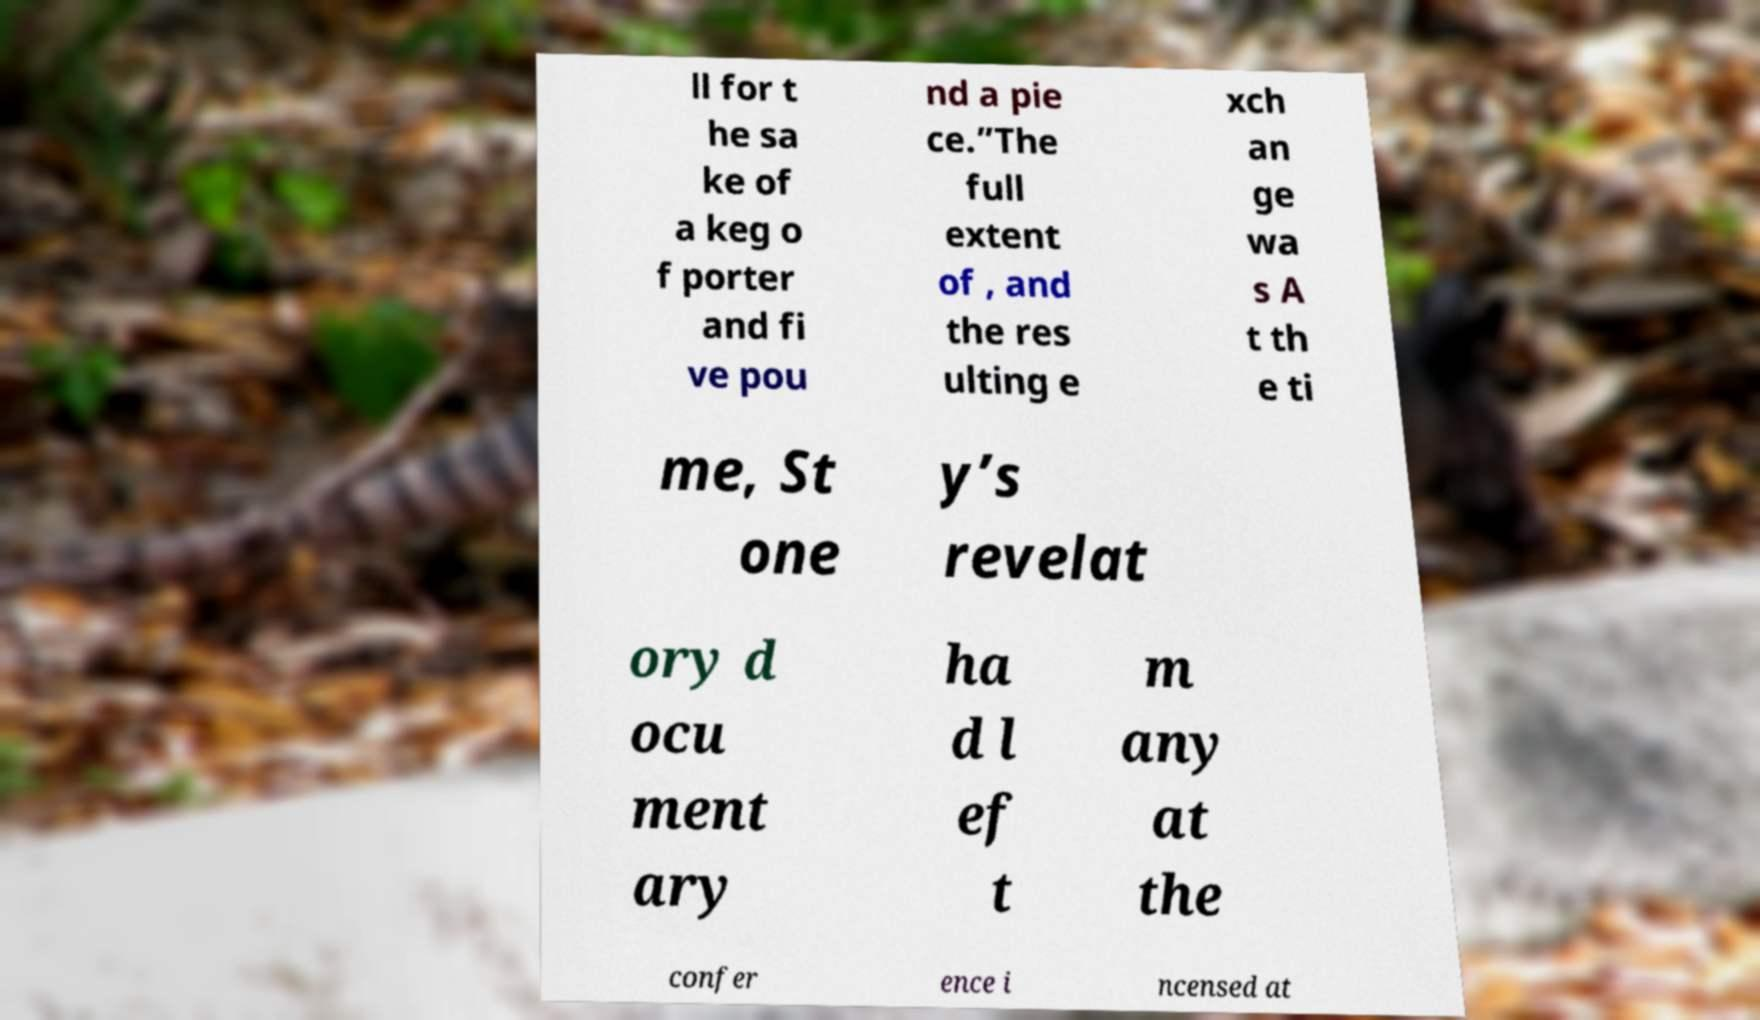Can you accurately transcribe the text from the provided image for me? ll for t he sa ke of a keg o f porter and fi ve pou nd a pie ce.”The full extent of , and the res ulting e xch an ge wa s A t th e ti me, St one y’s revelat ory d ocu ment ary ha d l ef t m any at the confer ence i ncensed at 